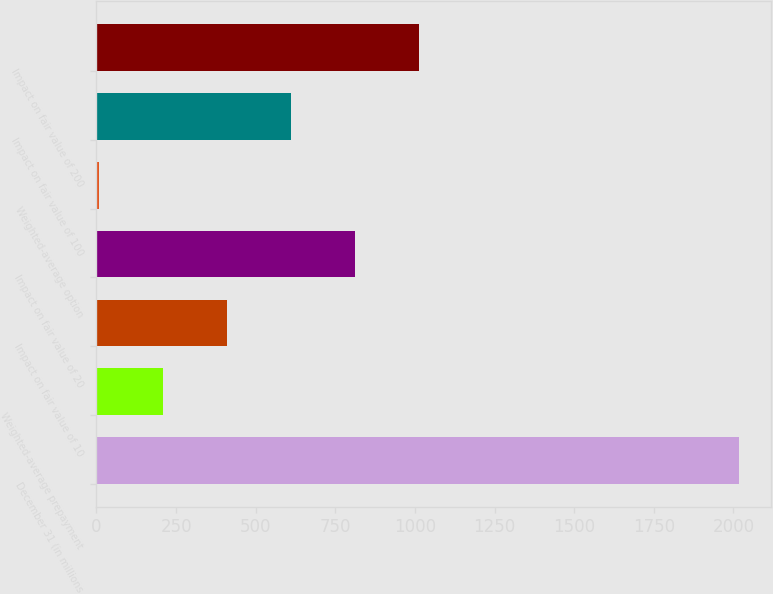Convert chart to OTSL. <chart><loc_0><loc_0><loc_500><loc_500><bar_chart><fcel>December 31 (in millions<fcel>Weighted-average prepayment<fcel>Impact on fair value of 10<fcel>Impact on fair value of 20<fcel>Weighted-average option<fcel>Impact on fair value of 100<fcel>Impact on fair value of 200<nl><fcel>2017<fcel>209.84<fcel>410.64<fcel>812.24<fcel>9.04<fcel>611.44<fcel>1013.04<nl></chart> 